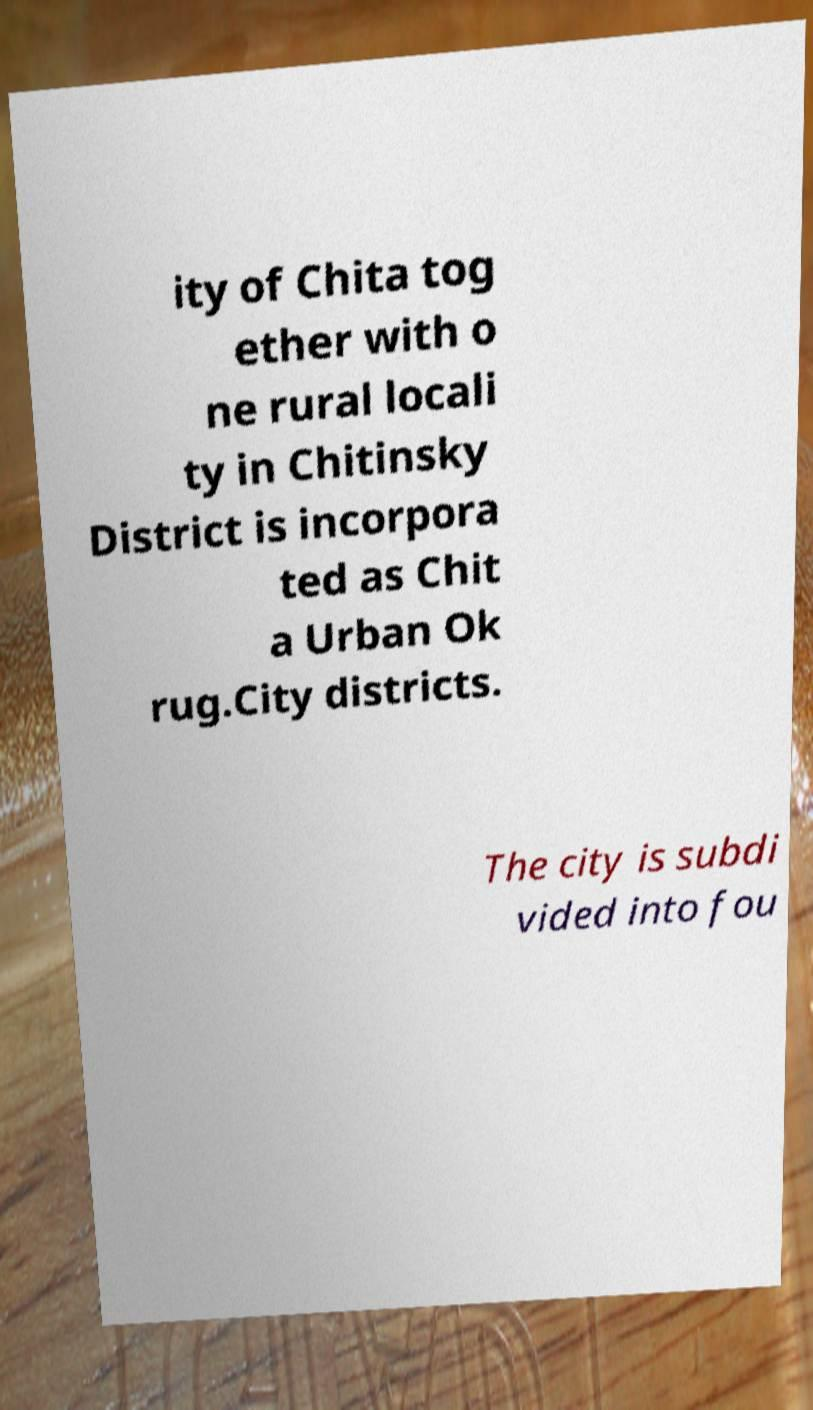I need the written content from this picture converted into text. Can you do that? ity of Chita tog ether with o ne rural locali ty in Chitinsky District is incorpora ted as Chit a Urban Ok rug.City districts. The city is subdi vided into fou 